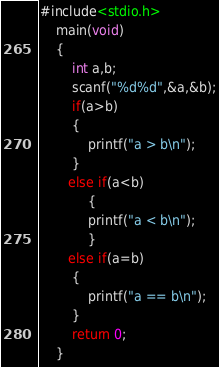<code> <loc_0><loc_0><loc_500><loc_500><_C_>#include<stdio.h>
    main(void)
    {
        int a,b;
        scanf("%d%d",&a,&b);
        if(a>b)
        {
            printf("a > b\n");
        }
       else if(a<b)
            {
            printf("a < b\n");
            }
       else if(a=b)
        {
            printf("a == b\n");
        }
        return 0;
    }</code> 